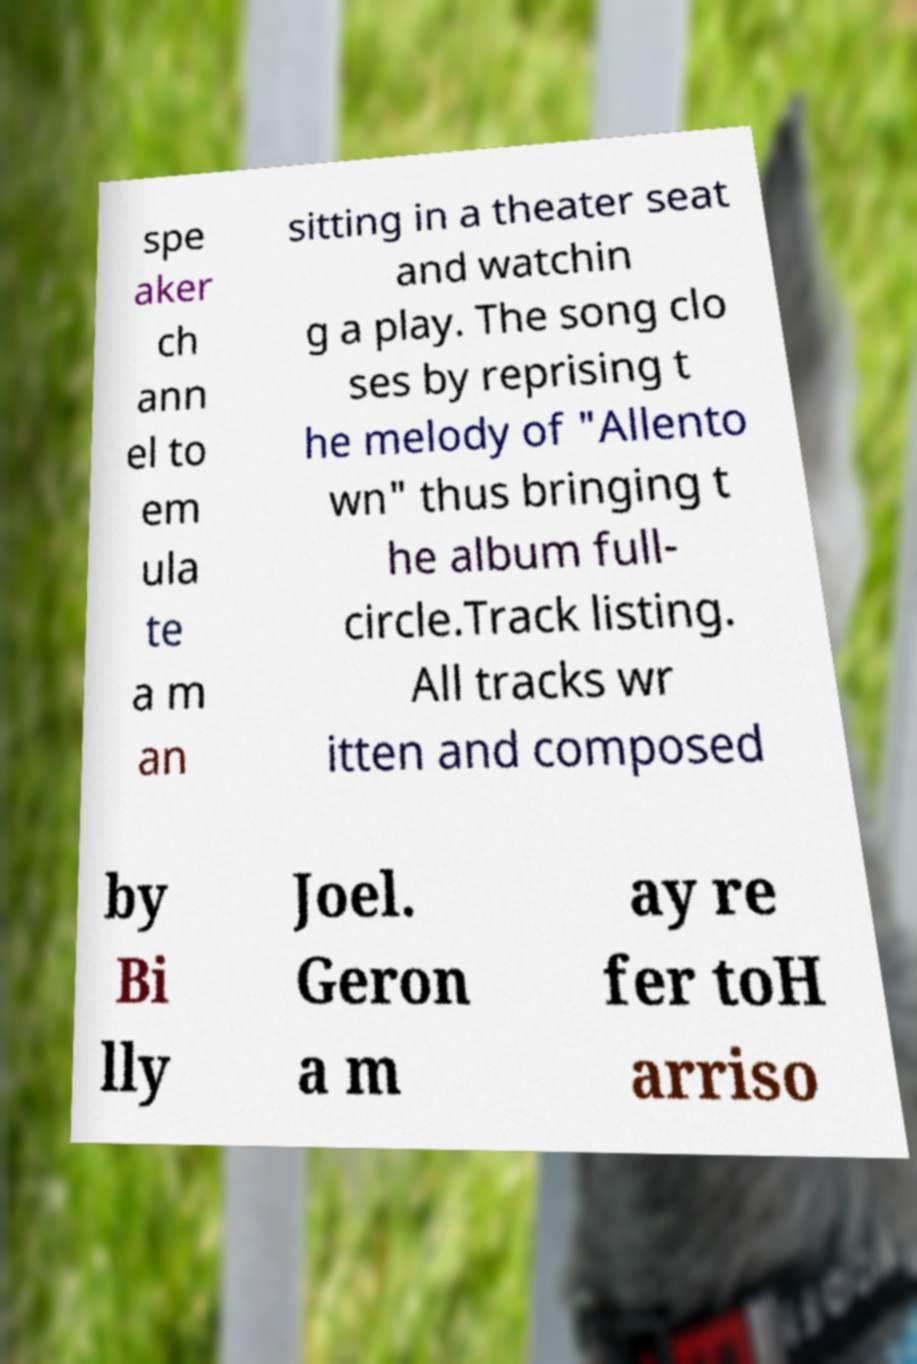Can you accurately transcribe the text from the provided image for me? spe aker ch ann el to em ula te a m an sitting in a theater seat and watchin g a play. The song clo ses by reprising t he melody of "Allento wn" thus bringing t he album full- circle.Track listing. All tracks wr itten and composed by Bi lly Joel. Geron a m ay re fer toH arriso 